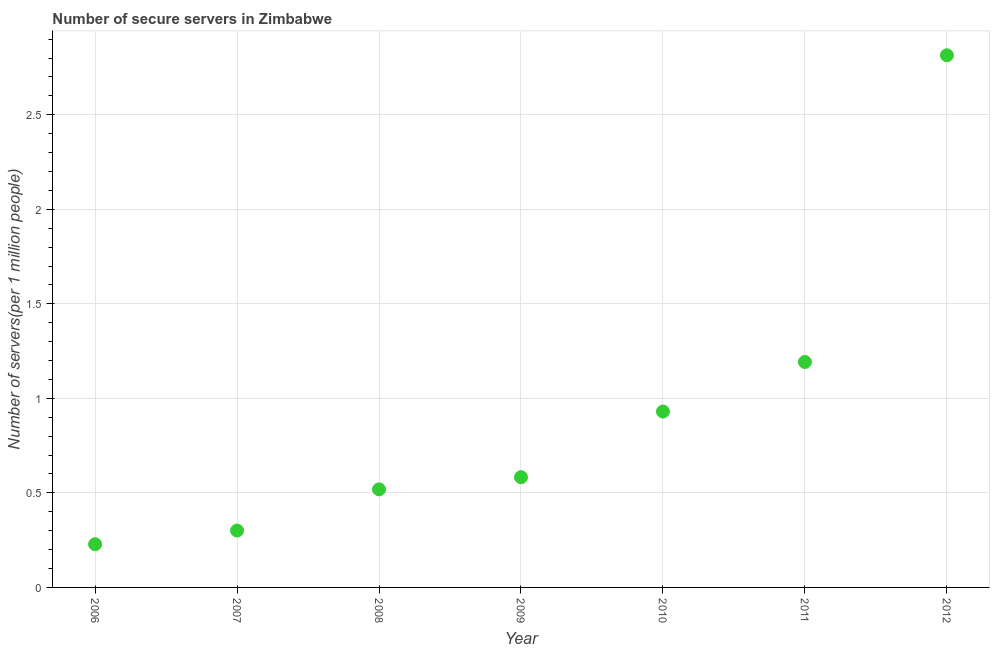What is the number of secure internet servers in 2010?
Make the answer very short. 0.93. Across all years, what is the maximum number of secure internet servers?
Keep it short and to the point. 2.81. Across all years, what is the minimum number of secure internet servers?
Your answer should be very brief. 0.23. In which year was the number of secure internet servers maximum?
Offer a terse response. 2012. What is the sum of the number of secure internet servers?
Offer a terse response. 6.57. What is the difference between the number of secure internet servers in 2007 and 2010?
Offer a very short reply. -0.63. What is the average number of secure internet servers per year?
Make the answer very short. 0.94. What is the median number of secure internet servers?
Keep it short and to the point. 0.58. What is the ratio of the number of secure internet servers in 2008 to that in 2009?
Your response must be concise. 0.89. Is the number of secure internet servers in 2010 less than that in 2012?
Provide a succinct answer. Yes. What is the difference between the highest and the second highest number of secure internet servers?
Ensure brevity in your answer.  1.62. What is the difference between the highest and the lowest number of secure internet servers?
Offer a very short reply. 2.59. What is the difference between two consecutive major ticks on the Y-axis?
Your answer should be very brief. 0.5. Are the values on the major ticks of Y-axis written in scientific E-notation?
Provide a short and direct response. No. What is the title of the graph?
Your answer should be very brief. Number of secure servers in Zimbabwe. What is the label or title of the X-axis?
Your answer should be very brief. Year. What is the label or title of the Y-axis?
Your answer should be very brief. Number of servers(per 1 million people). What is the Number of servers(per 1 million people) in 2006?
Ensure brevity in your answer.  0.23. What is the Number of servers(per 1 million people) in 2007?
Provide a short and direct response. 0.3. What is the Number of servers(per 1 million people) in 2008?
Offer a very short reply. 0.52. What is the Number of servers(per 1 million people) in 2009?
Give a very brief answer. 0.58. What is the Number of servers(per 1 million people) in 2010?
Your response must be concise. 0.93. What is the Number of servers(per 1 million people) in 2011?
Provide a short and direct response. 1.19. What is the Number of servers(per 1 million people) in 2012?
Give a very brief answer. 2.81. What is the difference between the Number of servers(per 1 million people) in 2006 and 2007?
Your answer should be compact. -0.07. What is the difference between the Number of servers(per 1 million people) in 2006 and 2008?
Make the answer very short. -0.29. What is the difference between the Number of servers(per 1 million people) in 2006 and 2009?
Your answer should be very brief. -0.35. What is the difference between the Number of servers(per 1 million people) in 2006 and 2010?
Your answer should be very brief. -0.7. What is the difference between the Number of servers(per 1 million people) in 2006 and 2011?
Give a very brief answer. -0.96. What is the difference between the Number of servers(per 1 million people) in 2006 and 2012?
Your response must be concise. -2.59. What is the difference between the Number of servers(per 1 million people) in 2007 and 2008?
Offer a terse response. -0.22. What is the difference between the Number of servers(per 1 million people) in 2007 and 2009?
Provide a short and direct response. -0.28. What is the difference between the Number of servers(per 1 million people) in 2007 and 2010?
Your answer should be compact. -0.63. What is the difference between the Number of servers(per 1 million people) in 2007 and 2011?
Ensure brevity in your answer.  -0.89. What is the difference between the Number of servers(per 1 million people) in 2007 and 2012?
Give a very brief answer. -2.51. What is the difference between the Number of servers(per 1 million people) in 2008 and 2009?
Offer a terse response. -0.06. What is the difference between the Number of servers(per 1 million people) in 2008 and 2010?
Provide a short and direct response. -0.41. What is the difference between the Number of servers(per 1 million people) in 2008 and 2011?
Provide a succinct answer. -0.67. What is the difference between the Number of servers(per 1 million people) in 2008 and 2012?
Offer a very short reply. -2.3. What is the difference between the Number of servers(per 1 million people) in 2009 and 2010?
Keep it short and to the point. -0.35. What is the difference between the Number of servers(per 1 million people) in 2009 and 2011?
Provide a short and direct response. -0.61. What is the difference between the Number of servers(per 1 million people) in 2009 and 2012?
Keep it short and to the point. -2.23. What is the difference between the Number of servers(per 1 million people) in 2010 and 2011?
Provide a succinct answer. -0.26. What is the difference between the Number of servers(per 1 million people) in 2010 and 2012?
Keep it short and to the point. -1.88. What is the difference between the Number of servers(per 1 million people) in 2011 and 2012?
Your answer should be very brief. -1.62. What is the ratio of the Number of servers(per 1 million people) in 2006 to that in 2007?
Offer a terse response. 0.76. What is the ratio of the Number of servers(per 1 million people) in 2006 to that in 2008?
Offer a terse response. 0.44. What is the ratio of the Number of servers(per 1 million people) in 2006 to that in 2009?
Make the answer very short. 0.39. What is the ratio of the Number of servers(per 1 million people) in 2006 to that in 2010?
Your answer should be very brief. 0.25. What is the ratio of the Number of servers(per 1 million people) in 2006 to that in 2011?
Your answer should be very brief. 0.19. What is the ratio of the Number of servers(per 1 million people) in 2006 to that in 2012?
Offer a very short reply. 0.08. What is the ratio of the Number of servers(per 1 million people) in 2007 to that in 2008?
Your response must be concise. 0.58. What is the ratio of the Number of servers(per 1 million people) in 2007 to that in 2009?
Your answer should be compact. 0.52. What is the ratio of the Number of servers(per 1 million people) in 2007 to that in 2010?
Provide a succinct answer. 0.32. What is the ratio of the Number of servers(per 1 million people) in 2007 to that in 2011?
Make the answer very short. 0.25. What is the ratio of the Number of servers(per 1 million people) in 2007 to that in 2012?
Provide a succinct answer. 0.11. What is the ratio of the Number of servers(per 1 million people) in 2008 to that in 2009?
Your response must be concise. 0.89. What is the ratio of the Number of servers(per 1 million people) in 2008 to that in 2010?
Give a very brief answer. 0.56. What is the ratio of the Number of servers(per 1 million people) in 2008 to that in 2011?
Your answer should be very brief. 0.43. What is the ratio of the Number of servers(per 1 million people) in 2008 to that in 2012?
Offer a terse response. 0.18. What is the ratio of the Number of servers(per 1 million people) in 2009 to that in 2010?
Offer a very short reply. 0.63. What is the ratio of the Number of servers(per 1 million people) in 2009 to that in 2011?
Offer a terse response. 0.49. What is the ratio of the Number of servers(per 1 million people) in 2009 to that in 2012?
Provide a succinct answer. 0.21. What is the ratio of the Number of servers(per 1 million people) in 2010 to that in 2011?
Give a very brief answer. 0.78. What is the ratio of the Number of servers(per 1 million people) in 2010 to that in 2012?
Your answer should be compact. 0.33. What is the ratio of the Number of servers(per 1 million people) in 2011 to that in 2012?
Offer a terse response. 0.42. 